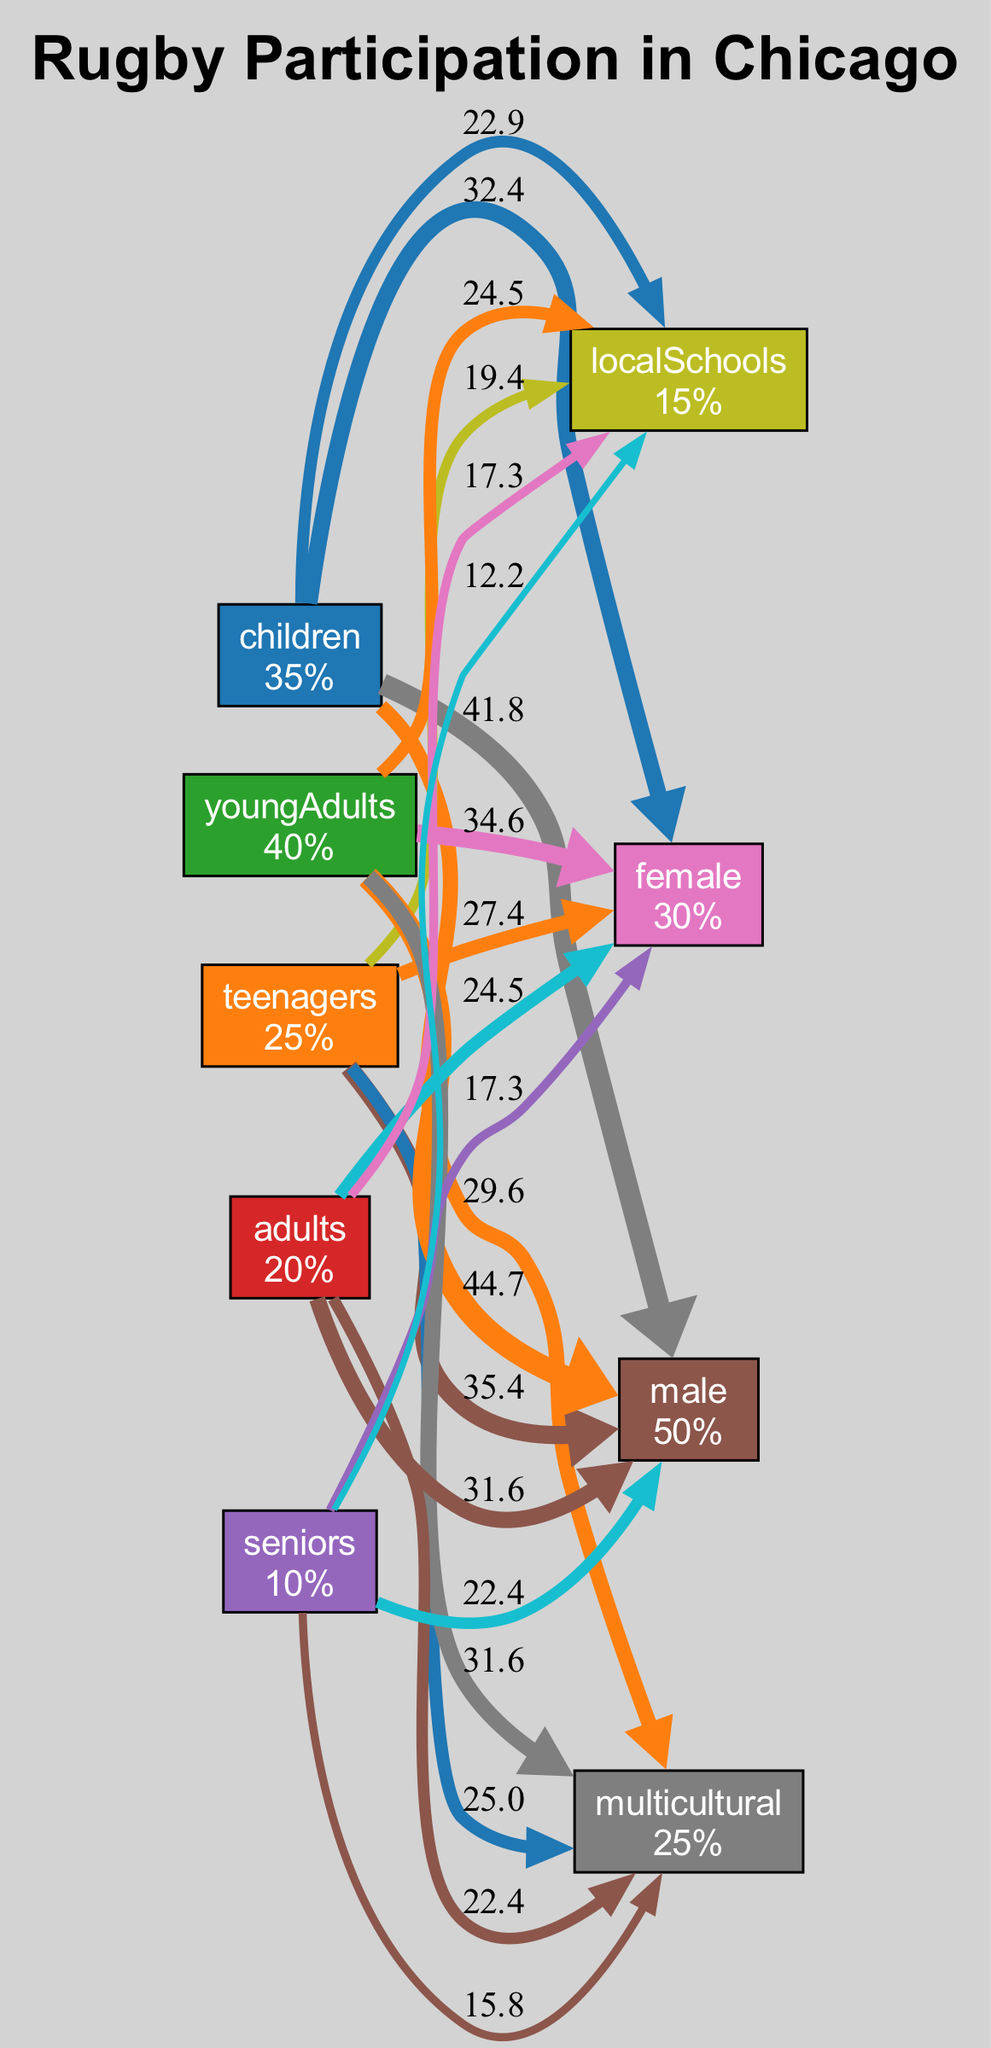What is the participation rate of children in rugby? The diagram shows that the node representing children has a participation rate labeled as 35%.
Answer: 35% Which age group has the highest participation rate? By comparing the participation rates of all age groups, young adults have the highest rate at 40%.
Answer: Young adults What demographic has the lowest participation rate? The demographics node for seniors shows the lowest participation rate labeled as 10%.
Answer: Seniors How many demographics are represented in the diagram? Counting all the nodes categorized under demographics, there are four demographics shown in the diagram.
Answer: Four What is the growth pattern for young adults? The diagram provides the growth pattern for young adults as "sharp increase from 2019 to 2023".
Answer: Sharp increase from 2019 to 2023 Which age group shows a stable growth pattern since 2015? Inspecting the growth patterns, the children age group is noted to have "increasing steadily since 2015".
Answer: Children Which demographic category has particularly strong growth? The demographic node for male indicates "strong growth among young adult males".
Answer: Male What is the relationship between participation rates for multicultural and local schools? By analyzing the edge weights, the multicultural demographic has a participation rate of 25% while local schools have a rate of 15%, showing that multicultural participation is higher.
Answer: Multicultural is higher What significant change in participation rate occurred in 2021 for local schools? The diagram states, "new programs introduced in 2021 boosted interest," indicating a noteworthy increase in participation starting that year.
Answer: New programs introduced increased interest 